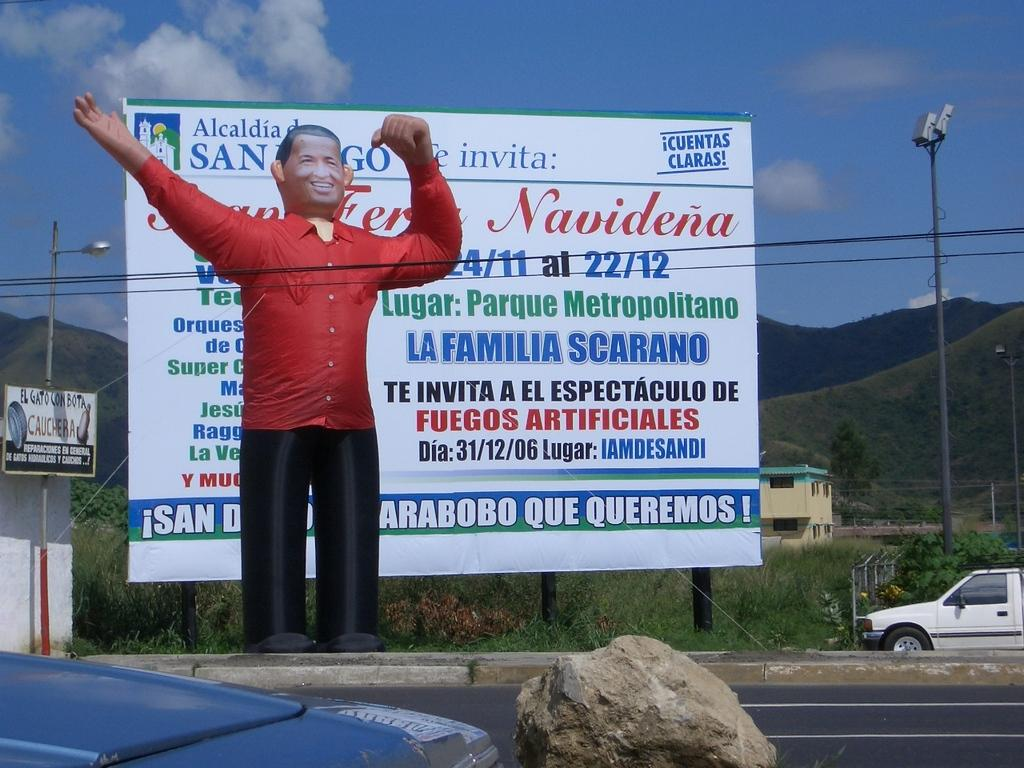Provide a one-sentence caption for the provided image. The billboard behind the fake person is for La Familia Scarano. 